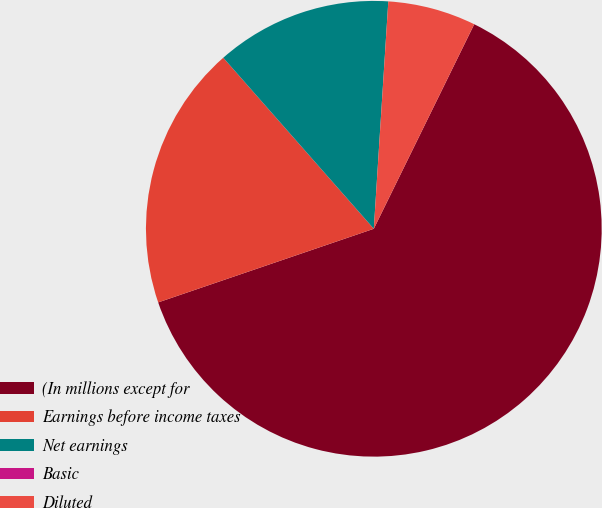Convert chart. <chart><loc_0><loc_0><loc_500><loc_500><pie_chart><fcel>(In millions except for<fcel>Earnings before income taxes<fcel>Net earnings<fcel>Basic<fcel>Diluted<nl><fcel>62.5%<fcel>18.75%<fcel>12.5%<fcel>0.0%<fcel>6.25%<nl></chart> 